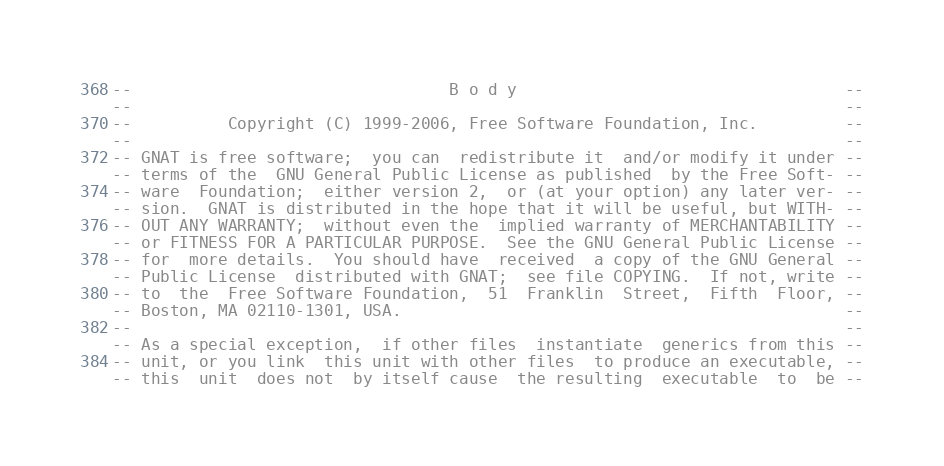<code> <loc_0><loc_0><loc_500><loc_500><_Ada_>--                                 B o d y                                  --
--                                                                          --
--          Copyright (C) 1999-2006, Free Software Foundation, Inc.         --
--                                                                          --
-- GNAT is free software;  you can  redistribute it  and/or modify it under --
-- terms of the  GNU General Public License as published  by the Free Soft- --
-- ware  Foundation;  either version 2,  or (at your option) any later ver- --
-- sion.  GNAT is distributed in the hope that it will be useful, but WITH- --
-- OUT ANY WARRANTY;  without even the  implied warranty of MERCHANTABILITY --
-- or FITNESS FOR A PARTICULAR PURPOSE.  See the GNU General Public License --
-- for  more details.  You should have  received  a copy of the GNU General --
-- Public License  distributed with GNAT;  see file COPYING.  If not, write --
-- to  the  Free Software Foundation,  51  Franklin  Street,  Fifth  Floor, --
-- Boston, MA 02110-1301, USA.                                              --
--                                                                          --
-- As a special exception,  if other files  instantiate  generics from this --
-- unit, or you link  this unit with other files  to produce an executable, --
-- this  unit  does not  by itself cause  the resulting  executable  to  be --</code> 